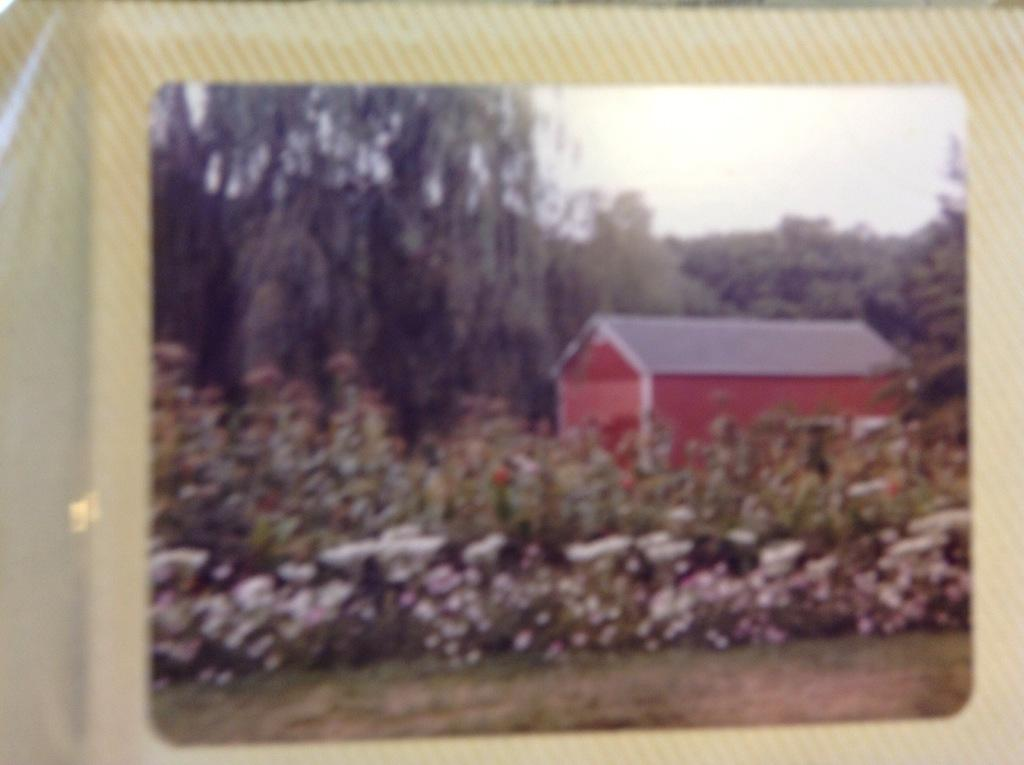What is the main subject of the poster in the image? The main subject of the poster in the image is a scene that includes a house, flower plants, trees, and the sky. Can you describe the elements depicted on the poster? Yes, there are flower plants, a house, trees, and the sky depicted on the poster. What is the background of the scene depicted on the poster? The background of the scene depicted on the poster includes the sky. What type of alarm can be heard going off in the image? There is no alarm present in the image, as it is a poster depicting a scene with a house, flower plants, trees, and the sky. 